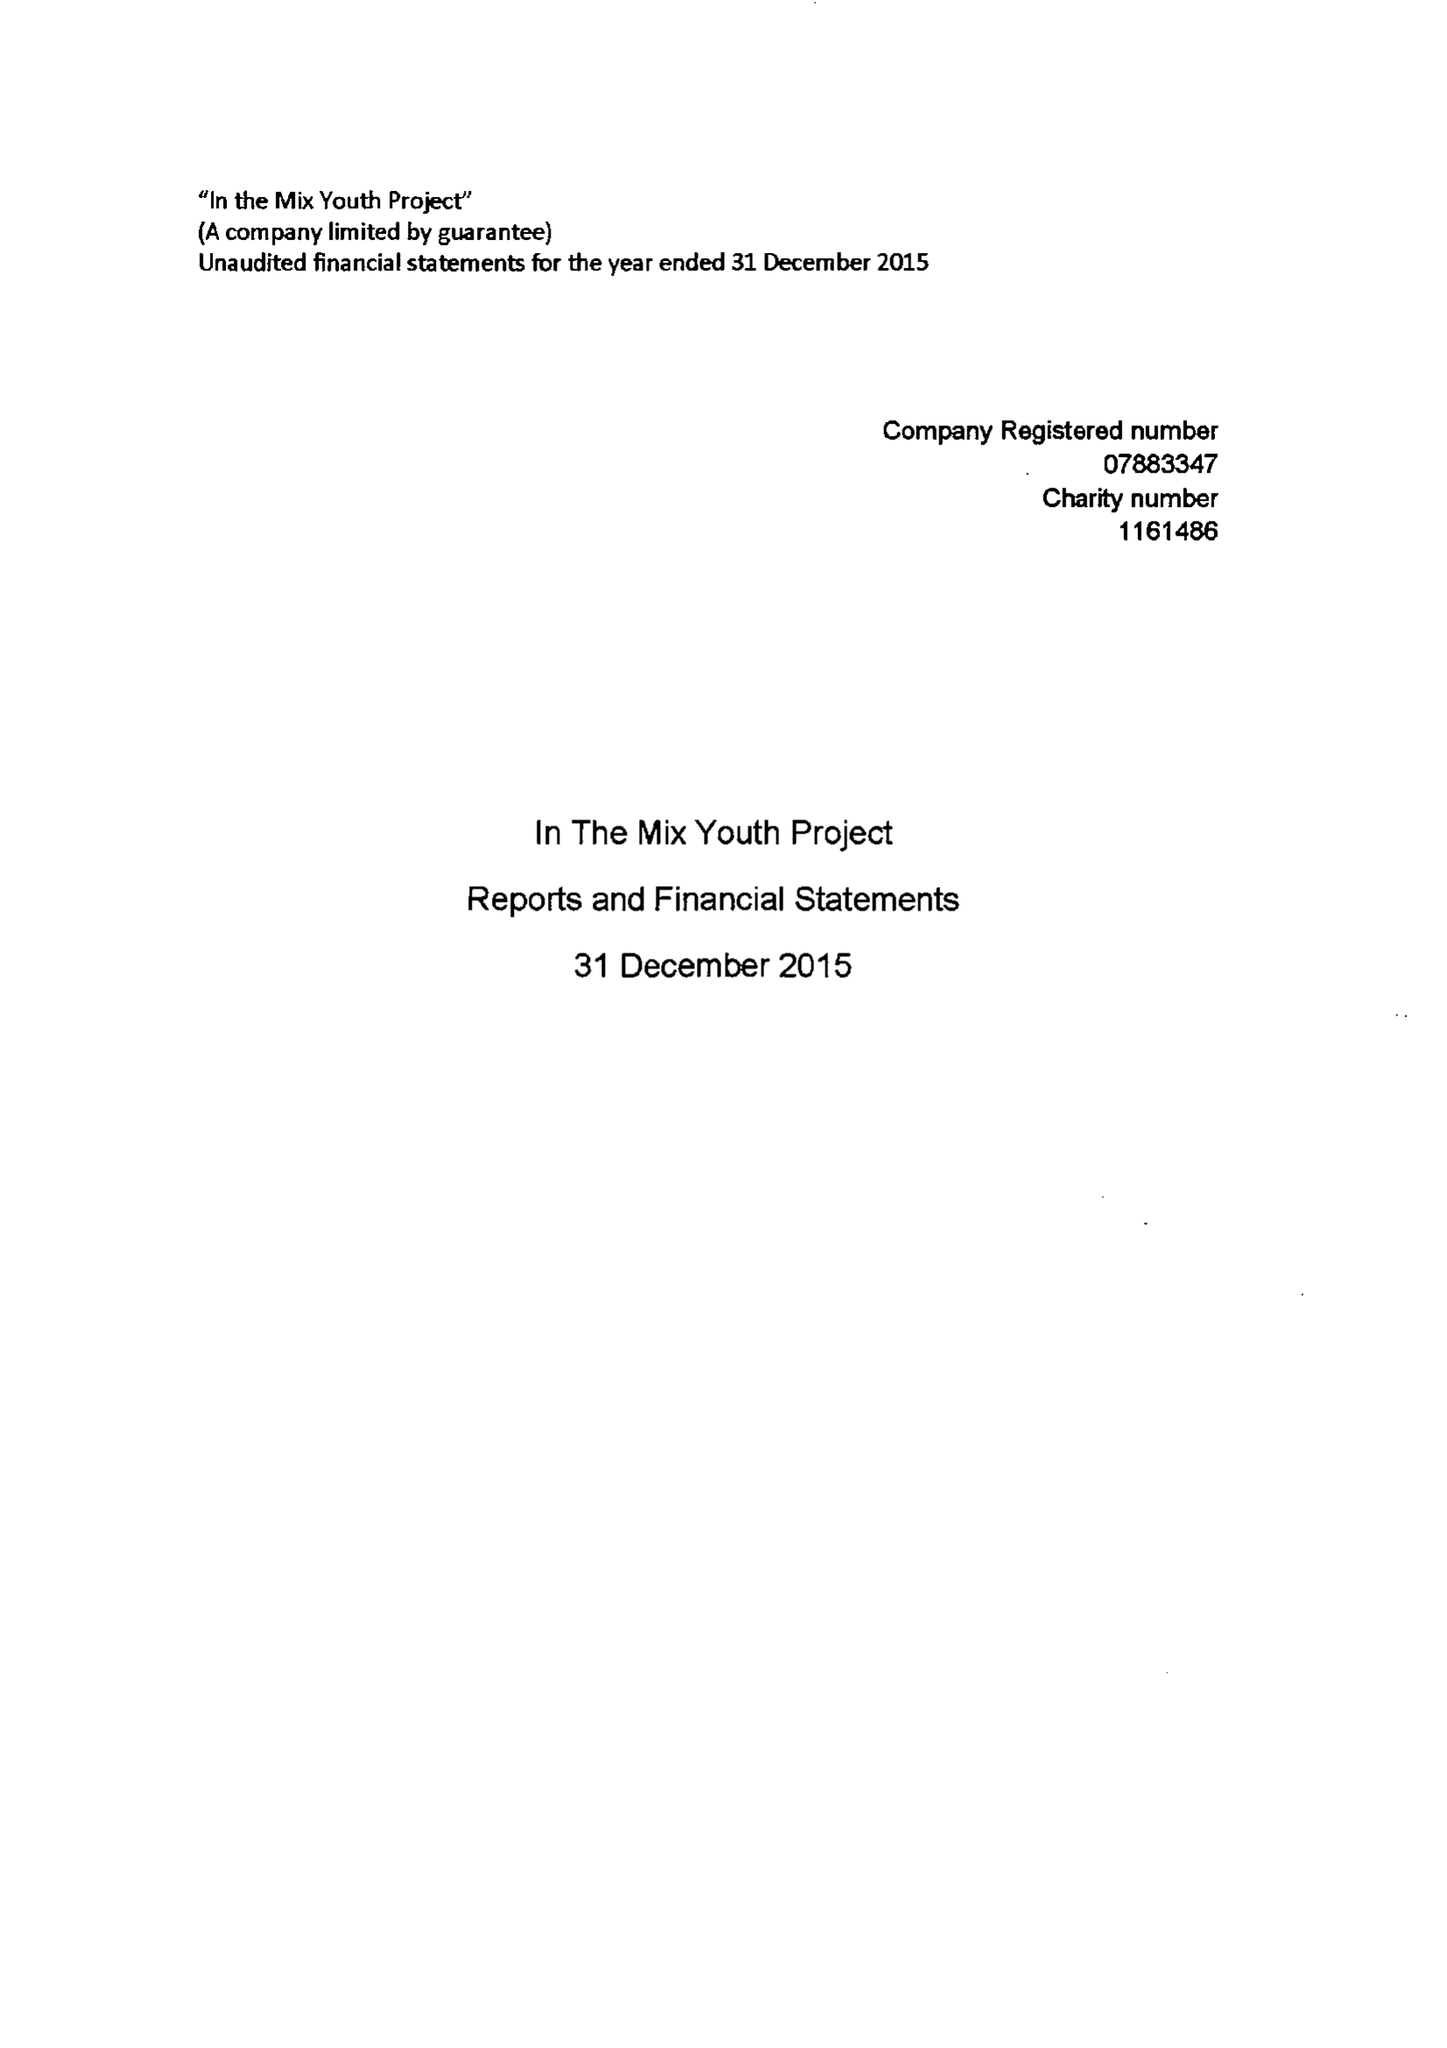What is the value for the income_annually_in_british_pounds?
Answer the question using a single word or phrase. 30455.00 